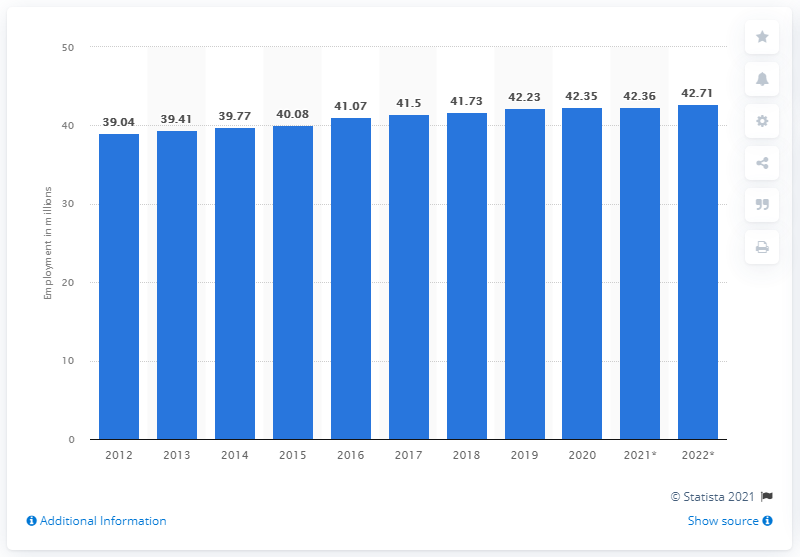Draw attention to some important aspects in this diagram. In 2020, the unemployment rate in Germany came to an end. In 2020, the number of people employed in Germany was 42.71. In the year 2020, the unemployment rate in Germany came to an end. 